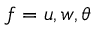<formula> <loc_0><loc_0><loc_500><loc_500>f = u , w , \theta</formula> 